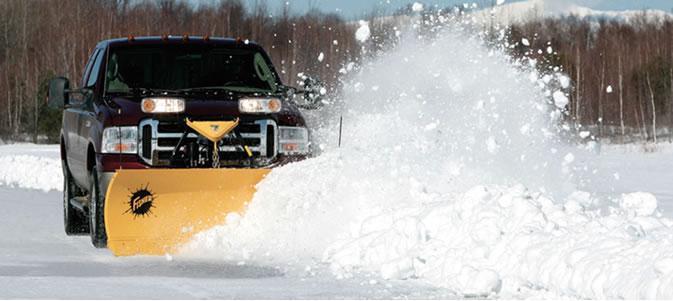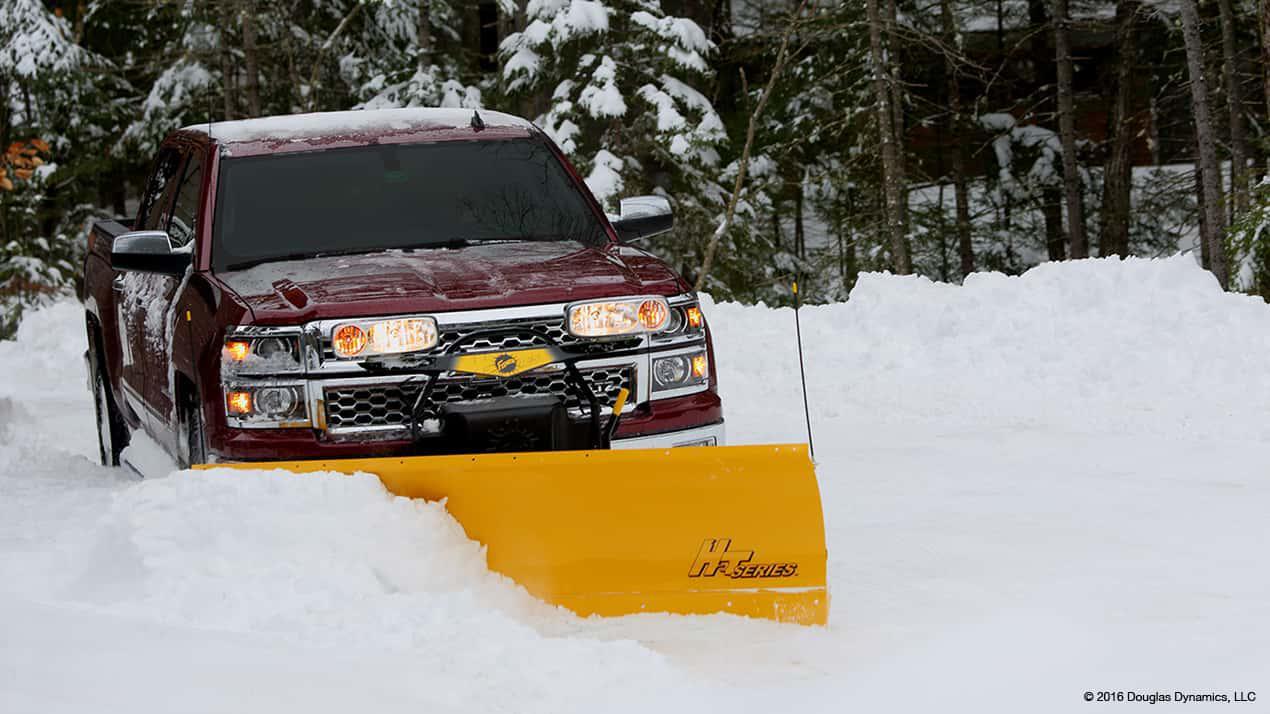The first image is the image on the left, the second image is the image on the right. Analyze the images presented: Is the assertion "There are two pick up trucks with a solid colored snow plow attached plowing snow." valid? Answer yes or no. Yes. 